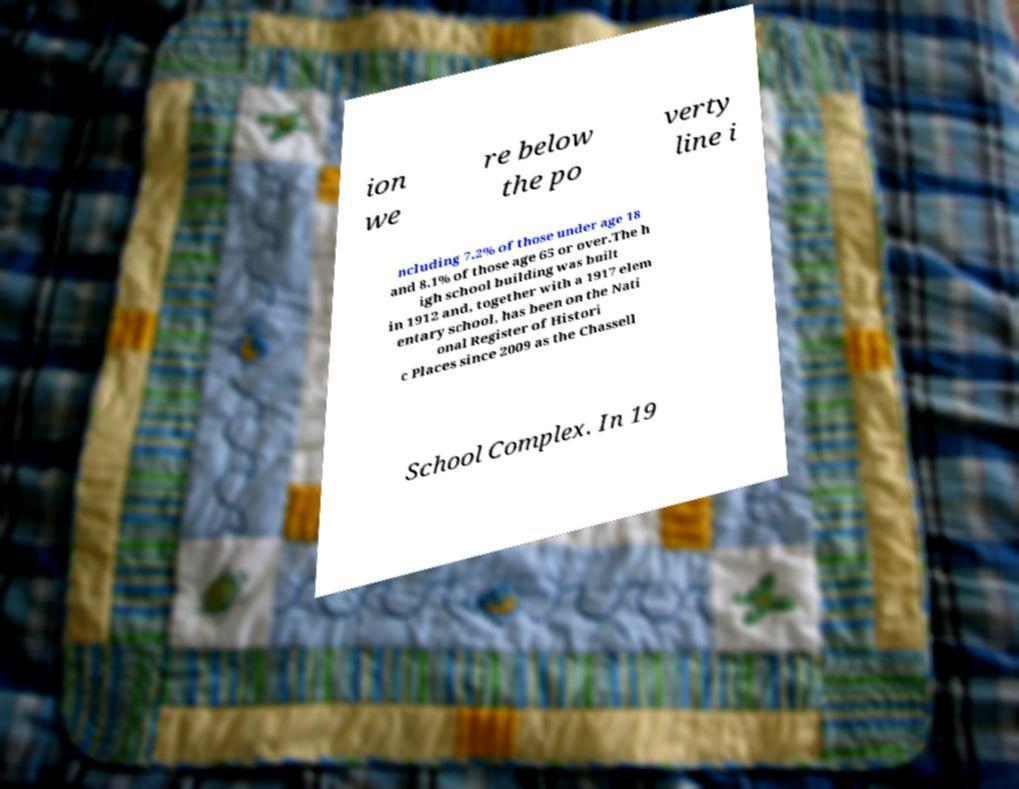Could you extract and type out the text from this image? ion we re below the po verty line i ncluding 7.2% of those under age 18 and 8.1% of those age 65 or over.The h igh school building was built in 1912 and, together with a 1917 elem entary school, has been on the Nati onal Register of Histori c Places since 2009 as the Chassell School Complex. In 19 